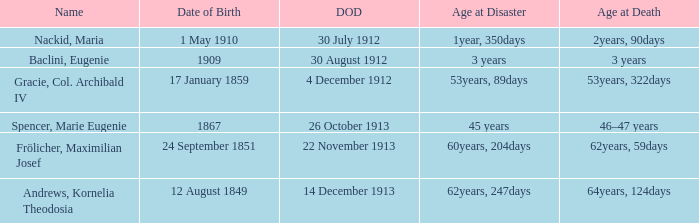How old was the person born 24 September 1851 at the time of disaster? 60years, 204days. 